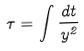<formula> <loc_0><loc_0><loc_500><loc_500>\tau = \int \frac { d t } { y ^ { 2 } }</formula> 